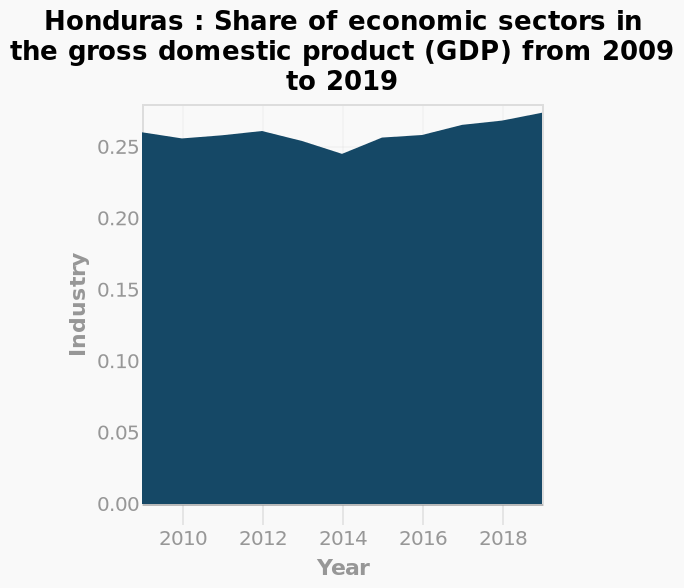<image>
Which economic sectors are depicted in the area plot for Honduras from 2009 to 2019?  The economic sectors depicted are Industry, Agriculture, and Services. Did the share of industries in the gross domestic product consistently increase or decrease between 2014 and 2019? The share of industries in the gross domestic product steadily increased between 2014 and 2019. What does the y-axis represent in the area plot for Honduras from 2009 to 2019?  The y-axis represents the share of Industry in the gross domestic product (GDP). What is the purpose of using an area plot to show the share of economic sectors in the GDP for Honduras from 2009 to 2019? The purpose is to visualize and compare the changes in the share of Industry, Agriculture, and Services in the GDP over the specified time period. 